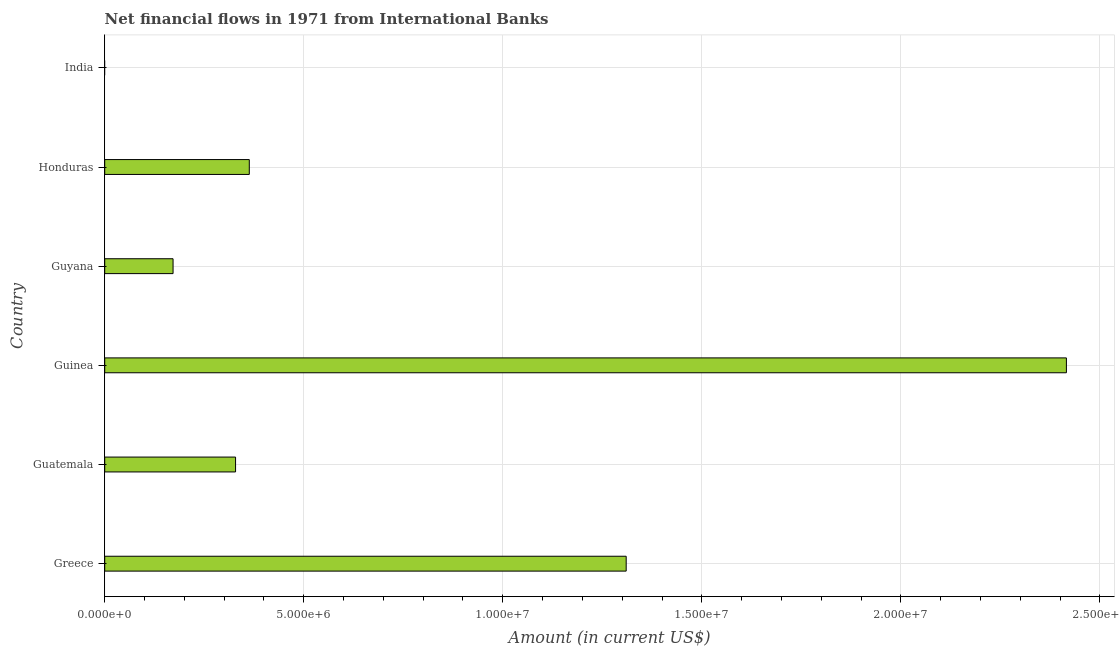What is the title of the graph?
Your answer should be very brief. Net financial flows in 1971 from International Banks. What is the label or title of the X-axis?
Offer a terse response. Amount (in current US$). What is the net financial flows from ibrd in Greece?
Ensure brevity in your answer.  1.31e+07. Across all countries, what is the maximum net financial flows from ibrd?
Make the answer very short. 2.42e+07. Across all countries, what is the minimum net financial flows from ibrd?
Your answer should be compact. 0. In which country was the net financial flows from ibrd maximum?
Provide a succinct answer. Guinea. What is the sum of the net financial flows from ibrd?
Keep it short and to the point. 4.59e+07. What is the difference between the net financial flows from ibrd in Guatemala and Honduras?
Offer a terse response. -3.45e+05. What is the average net financial flows from ibrd per country?
Your response must be concise. 7.65e+06. What is the median net financial flows from ibrd?
Keep it short and to the point. 3.46e+06. In how many countries, is the net financial flows from ibrd greater than 18000000 US$?
Your answer should be compact. 1. What is the ratio of the net financial flows from ibrd in Greece to that in Guatemala?
Offer a terse response. 3.98. Is the net financial flows from ibrd in Guatemala less than that in Guyana?
Make the answer very short. No. Is the difference between the net financial flows from ibrd in Greece and Guinea greater than the difference between any two countries?
Your answer should be compact. No. What is the difference between the highest and the second highest net financial flows from ibrd?
Provide a succinct answer. 1.11e+07. Is the sum of the net financial flows from ibrd in Greece and Honduras greater than the maximum net financial flows from ibrd across all countries?
Your answer should be compact. No. What is the difference between the highest and the lowest net financial flows from ibrd?
Provide a succinct answer. 2.42e+07. In how many countries, is the net financial flows from ibrd greater than the average net financial flows from ibrd taken over all countries?
Offer a terse response. 2. How many bars are there?
Offer a terse response. 5. Are all the bars in the graph horizontal?
Ensure brevity in your answer.  Yes. What is the Amount (in current US$) of Greece?
Give a very brief answer. 1.31e+07. What is the Amount (in current US$) of Guatemala?
Offer a terse response. 3.29e+06. What is the Amount (in current US$) in Guinea?
Ensure brevity in your answer.  2.42e+07. What is the Amount (in current US$) in Guyana?
Offer a very short reply. 1.72e+06. What is the Amount (in current US$) of Honduras?
Ensure brevity in your answer.  3.63e+06. What is the Amount (in current US$) in India?
Keep it short and to the point. 0. What is the difference between the Amount (in current US$) in Greece and Guatemala?
Provide a short and direct response. 9.81e+06. What is the difference between the Amount (in current US$) in Greece and Guinea?
Keep it short and to the point. -1.11e+07. What is the difference between the Amount (in current US$) in Greece and Guyana?
Your answer should be compact. 1.14e+07. What is the difference between the Amount (in current US$) in Greece and Honduras?
Your response must be concise. 9.47e+06. What is the difference between the Amount (in current US$) in Guatemala and Guinea?
Provide a short and direct response. -2.09e+07. What is the difference between the Amount (in current US$) in Guatemala and Guyana?
Ensure brevity in your answer.  1.57e+06. What is the difference between the Amount (in current US$) in Guatemala and Honduras?
Ensure brevity in your answer.  -3.45e+05. What is the difference between the Amount (in current US$) in Guinea and Guyana?
Keep it short and to the point. 2.24e+07. What is the difference between the Amount (in current US$) in Guinea and Honduras?
Give a very brief answer. 2.05e+07. What is the difference between the Amount (in current US$) in Guyana and Honduras?
Offer a very short reply. -1.92e+06. What is the ratio of the Amount (in current US$) in Greece to that in Guatemala?
Ensure brevity in your answer.  3.98. What is the ratio of the Amount (in current US$) in Greece to that in Guinea?
Make the answer very short. 0.54. What is the ratio of the Amount (in current US$) in Greece to that in Guyana?
Your answer should be compact. 7.63. What is the ratio of the Amount (in current US$) in Greece to that in Honduras?
Provide a short and direct response. 3.61. What is the ratio of the Amount (in current US$) in Guatemala to that in Guinea?
Provide a succinct answer. 0.14. What is the ratio of the Amount (in current US$) in Guatemala to that in Guyana?
Your answer should be compact. 1.91. What is the ratio of the Amount (in current US$) in Guatemala to that in Honduras?
Give a very brief answer. 0.91. What is the ratio of the Amount (in current US$) in Guinea to that in Guyana?
Give a very brief answer. 14.07. What is the ratio of the Amount (in current US$) in Guinea to that in Honduras?
Keep it short and to the point. 6.65. What is the ratio of the Amount (in current US$) in Guyana to that in Honduras?
Provide a succinct answer. 0.47. 